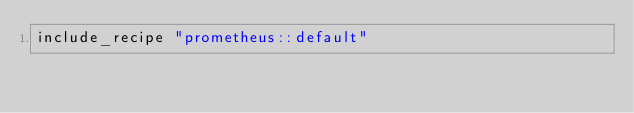Convert code to text. <code><loc_0><loc_0><loc_500><loc_500><_Ruby_>include_recipe "prometheus::default"
</code> 